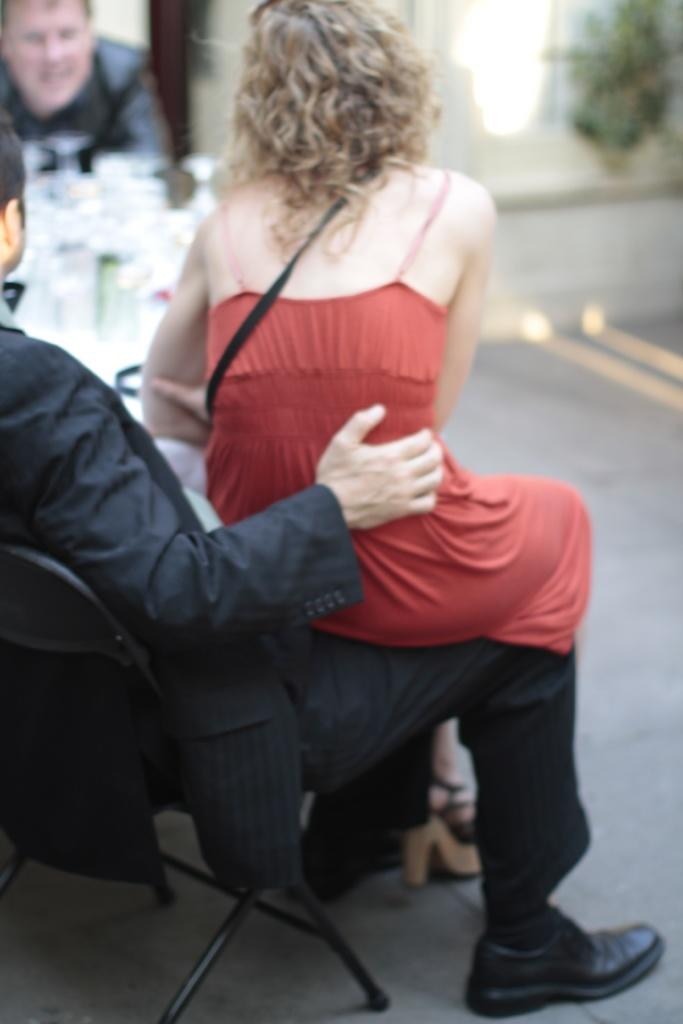What is the woman doing in the image? The woman is sitting on a person in the image. What is the person doing while the woman is sitting on them? The person is sitting on a chair. Can you describe the background of the image? The background of the image is blurred. What can be seen on the person's face in the image? There are glasses visible on the person's face. What else can be seen in the image besides the woman, person, and glasses? There are other unspecified things in the image. What type of attack is being carried out by the bears in the image? There are no bears present in the image; it features a woman sitting on a person. What is the cause of the thunder in the image? There is no thunder present in the image. 